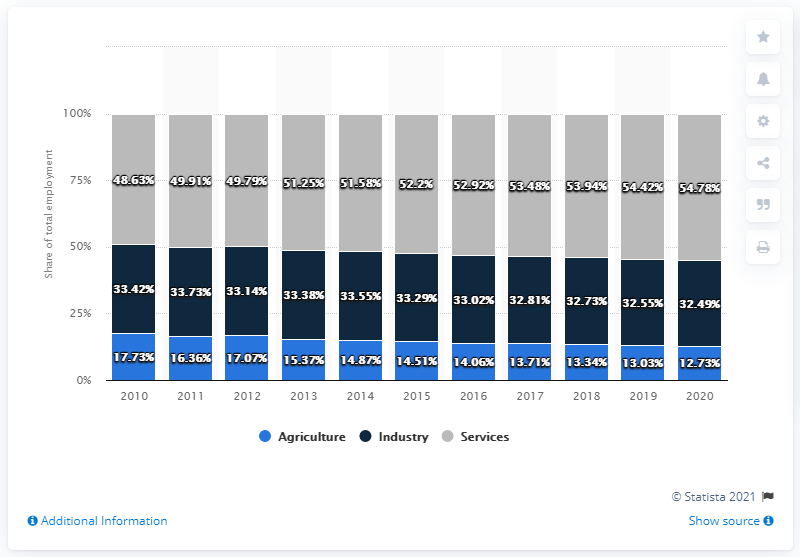Identify some key points in this picture. In 2020, the agriculture sector employed approximately 12.73% of the total workforce. The maximum share of the agriculture sector is 14.76, while the minimum share of the industry sector is 14.76. 